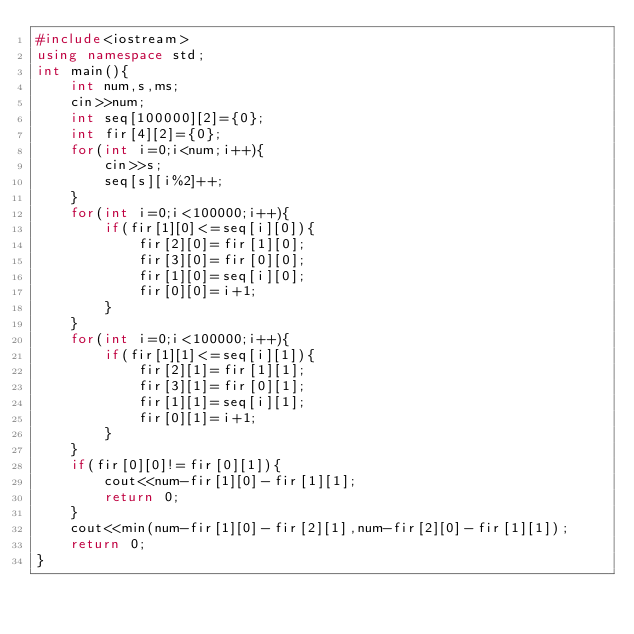Convert code to text. <code><loc_0><loc_0><loc_500><loc_500><_C++_>#include<iostream>
using namespace std;
int main(){
	int num,s,ms;
	cin>>num;
	int seq[100000][2]={0};
	int fir[4][2]={0};
	for(int i=0;i<num;i++){
		cin>>s;
		seq[s][i%2]++;
	}
	for(int i=0;i<100000;i++){
		if(fir[1][0]<=seq[i][0]){
			fir[2][0]=fir[1][0];
			fir[3][0]=fir[0][0];
			fir[1][0]=seq[i][0];
			fir[0][0]=i+1;
		}
	}
	for(int i=0;i<100000;i++){
		if(fir[1][1]<=seq[i][1]){
			fir[2][1]=fir[1][1];
			fir[3][1]=fir[0][1];
			fir[1][1]=seq[i][1];
			fir[0][1]=i+1;
		}
	}
	if(fir[0][0]!=fir[0][1]){
		cout<<num-fir[1][0]-fir[1][1];
		return 0;
	}
	cout<<min(num-fir[1][0]-fir[2][1],num-fir[2][0]-fir[1][1]);
	return 0;
}</code> 